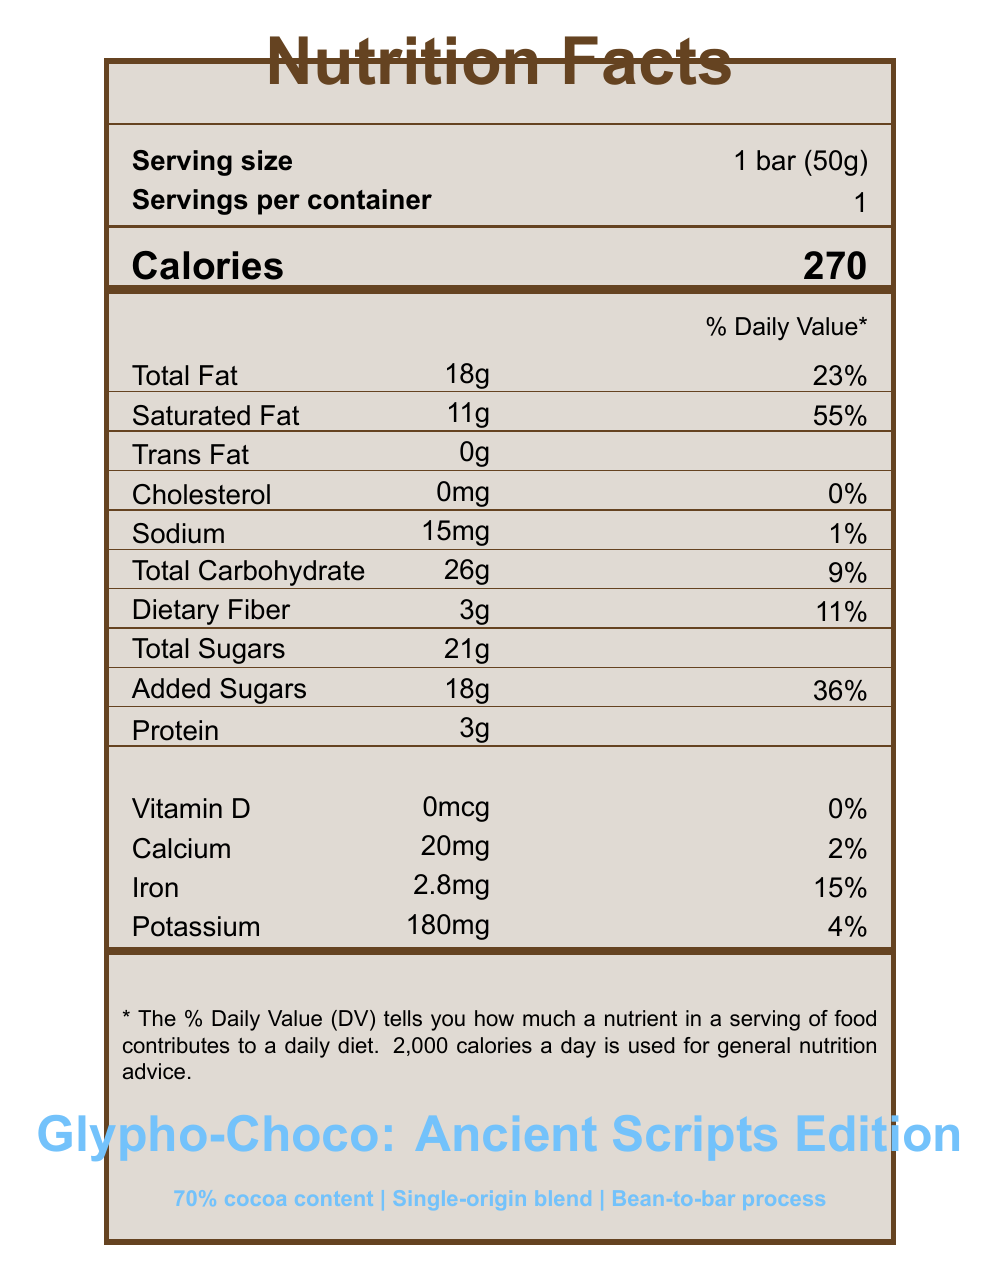What is the serving size of the Glypho-Choco bar? The serving size is listed as "1 bar (50g)" under the serving information.
Answer: 1 bar (50g) How many calories are in one serving of the Glypho-Choco bar? The document specifies that one serving size (1 bar) contains 270 calories.
Answer: 270 What percentage of the Daily Value for saturated fat does one Glypho-Choco bar provide? The saturated fat content is shown as 11g with a Daily Value percentage of 55%.
Answer: 55% What is the primary source location for the cocoa in the Glypho-Choco bar? The cocoa origin section lists "Maya Highlands, Guatemala" as the primary source location.
Answer: Maya Highlands, Guatemala How much protein does one Glypho-Choco bar contain? The protein content is listed as 3g on the nutrition facts label.
Answer: 3g What type of certification does the Glypho-Choco bar have? A. USDA Organic B. Fair Trade Certified C. Rainforest Alliance Certified D. All of the above The certification section lists all three: USDA Organic, Fair Trade Certified, and Rainforest Alliance Certified.
Answer: D. All of the above How much dietary fiber is in the Glypho-Choco bar and what is its Daily Value percentage? A. 2g, 9% B. 3g, 11% C. 4g, 13% The dietary fiber content is listed as 3g, with an 11% Daily Value percentage.
Answer: B. 3g, 11% Does the Glypho-Choco bar contain any added sugars? The nutrition facts include "Added Sugars" as 18g, which is 36% of the Daily Value.
Answer: Yes Is there any cholesterol in the Glypho-Choco bar? The document shows 0mg of cholesterol and a 0% Daily Value.
Answer: No Summarize the main features of the Glypho-Choco bar as presented in the document. The document details the nutrition facts, ingredients, origin of cocoa, certifications, special features, and company information of the Glypho-Choco bar.
Answer: The Glypho-Choco bar is a single-serving chocolate bar with 270 calories. It features high cocoa content of 70%, certifications like USDA Organic, and comes in eco-friendly packaging inspired by ancient scripts. Who is the designer of the custom font used on the Glypho-Choco bar packaging? The font details section states that the font "ScriptScript" was designed by Alessandra Fontana.
Answer: Alessandra Fontana Can you determine the price of the Glypho-Choco bar? The document does not provide any information regarding the price of the chocolate bar.
Answer: Cannot be determined Which of the following are special features of the Glypho-Choco bar? I. 70% cocoa content II. Single-origin blend III. Vegan The document lists "70% cocoa content", "Single-origin blend", and "Bean-to-bar process" as special features. "Vegan" is not mentioned.
Answer: I and II What is the allergen information for the Glypho-Choco bar? The allergen info section specifically states that the bar "May contain traces of nuts and milk."
Answer: May contain traces of nuts and milk How much iron does the Glypho-Choco bar provide and what is its Daily Value percentage? The iron content is listed as 2.8mg, which is 15% of the Daily Value.
Answer: 2.8mg, 15% 